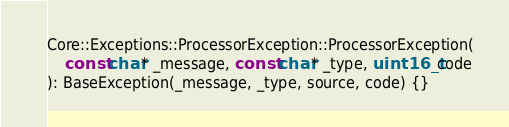Convert code to text. <code><loc_0><loc_0><loc_500><loc_500><_C++_>
Core::Exceptions::ProcessorException::ProcessorException(
    const char* _message, const char* _type, uint16_t code
): BaseException(_message, _type, source, code) {}</code> 